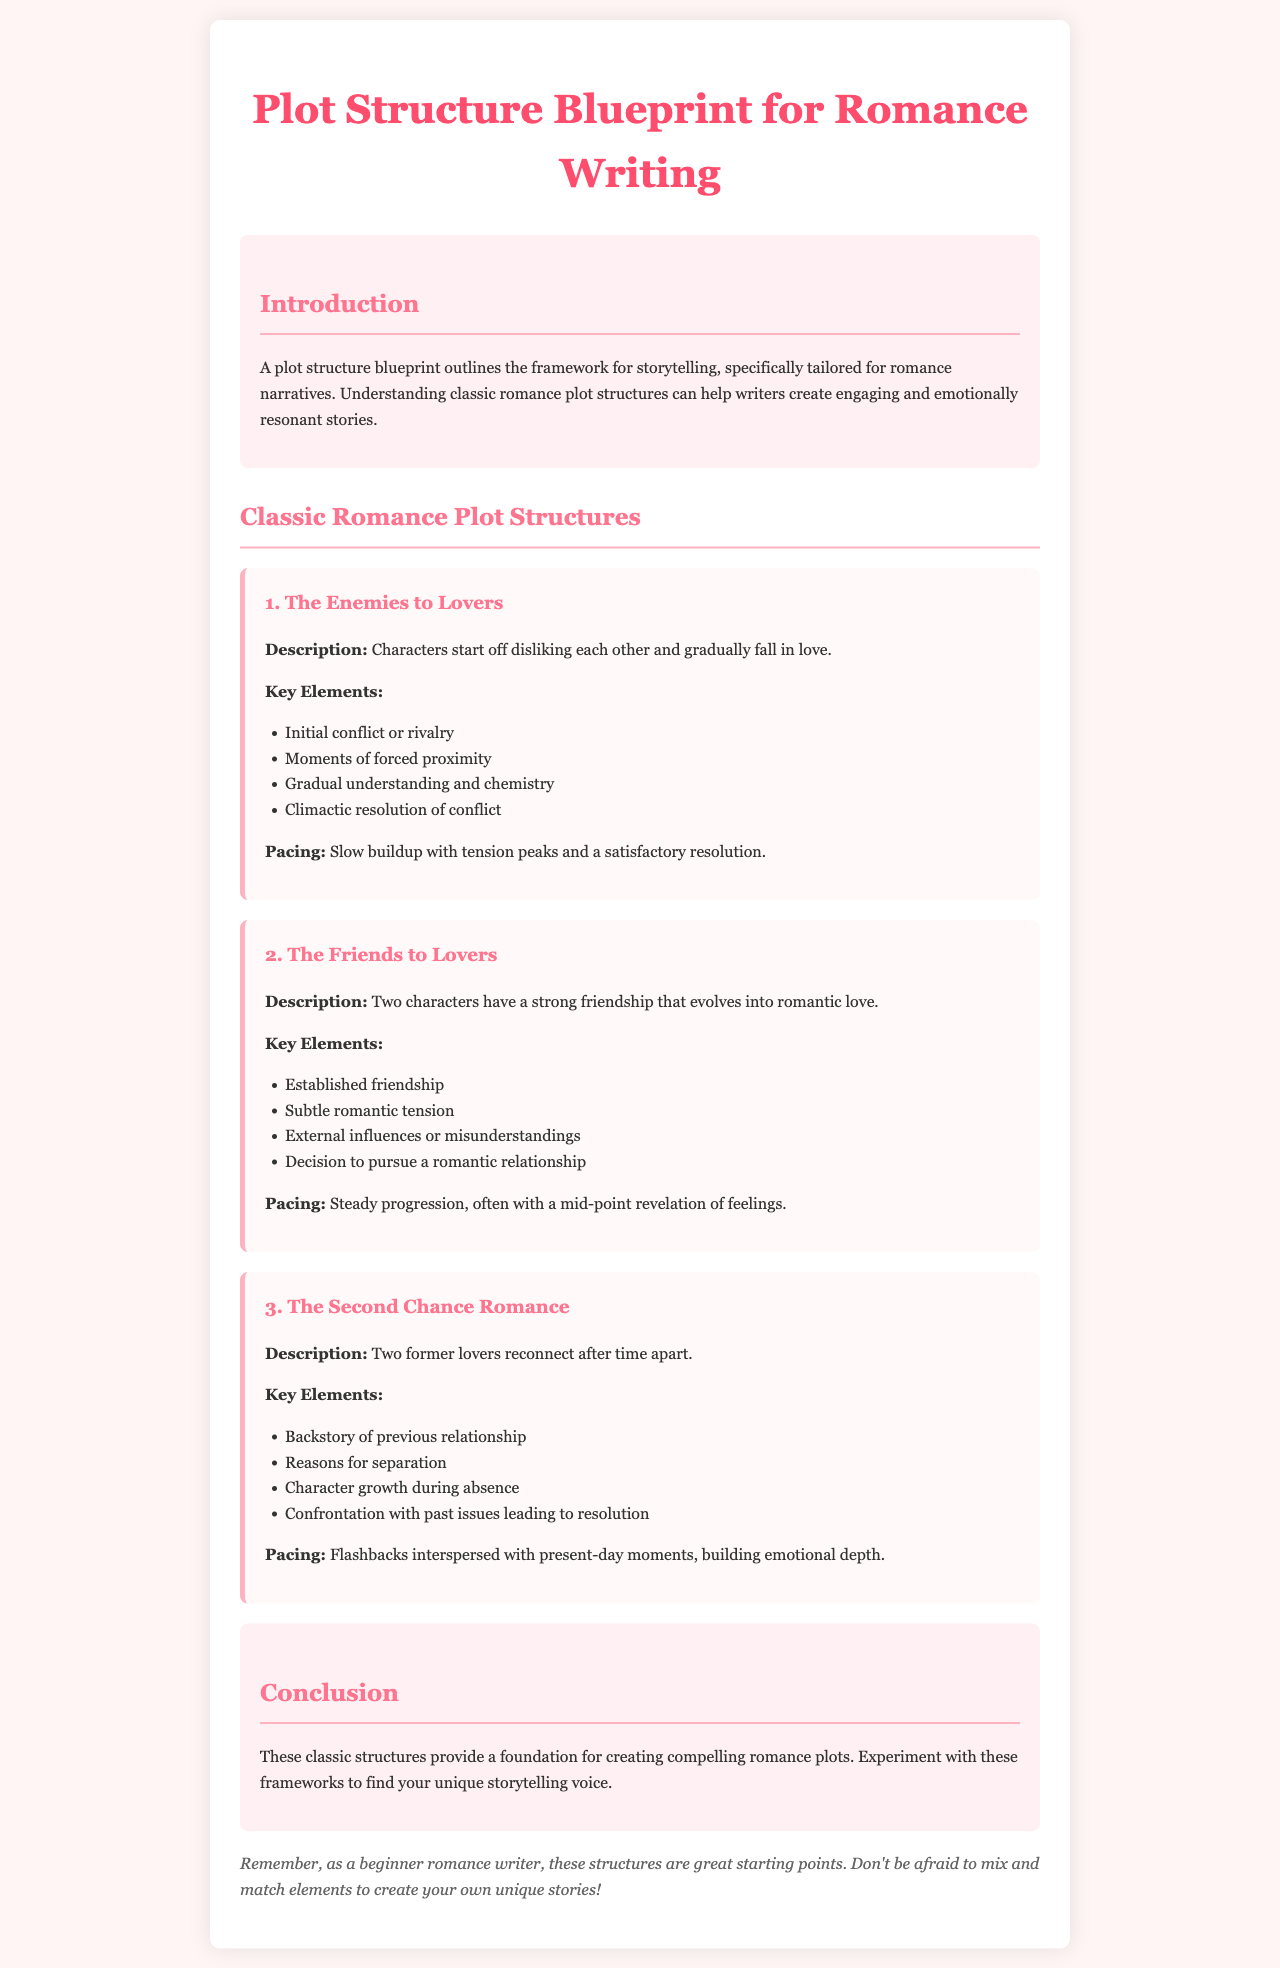What are the three classic romance plot structures mentioned? The document outlines three classic romance plot structures: Enemies to Lovers, Friends to Lovers, and Second Chance Romance.
Answer: Enemies to Lovers, Friends to Lovers, Second Chance Romance What is the pacing of the Enemies to Lovers structure? The pacing for the Enemies to Lovers structure involves a slow buildup with peaks of tension and a satisfactory resolution.
Answer: Slow buildup with tension peaks What key element is associated with the Friends to Lovers structure? An established friendship is a key element that characterizes the Friends to Lovers plot structure.
Answer: Established friendship What should beginner writers do with the provided structures? The document encourages beginner writers to experiment with the classic structures to find their unique storytelling voice.
Answer: Experiment with these frameworks What is included in the key elements of the Second Chance Romance? The key elements for the Second Chance Romance include a backstory of the previous relationship, which is crucial for understanding character dynamics.
Answer: Backstory of previous relationship 